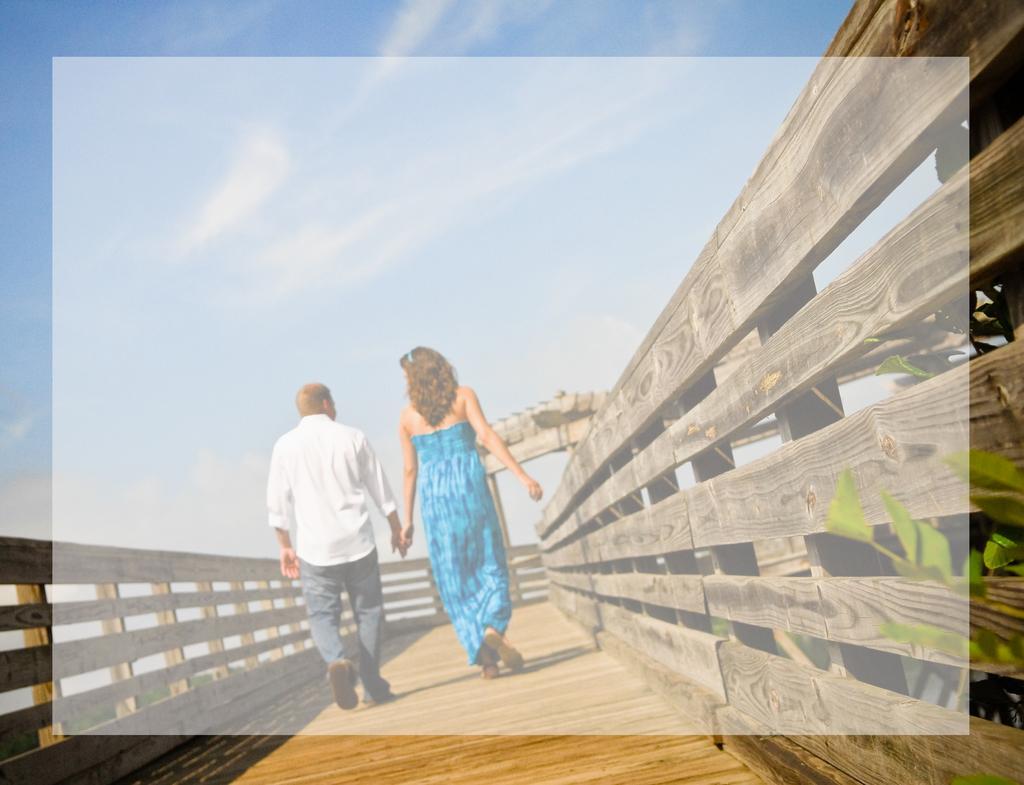Can you describe this image briefly? This image is clicked outside. There are two persons. One is a woman, another one is a man. There are holding each others hand. There is sky at the top. This looks like a small bridge built with wood. 